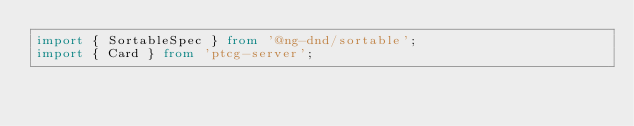<code> <loc_0><loc_0><loc_500><loc_500><_TypeScript_>import { SortableSpec } from '@ng-dnd/sortable';
import { Card } from 'ptcg-server';
</code> 